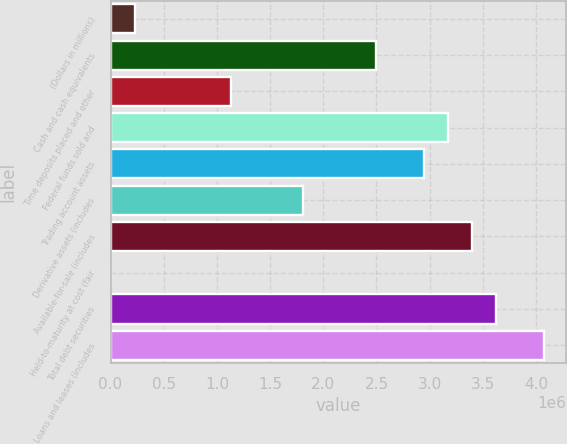<chart> <loc_0><loc_0><loc_500><loc_500><bar_chart><fcel>(Dollars in millions)<fcel>Cash and cash equivalents<fcel>Time deposits placed and other<fcel>Federal funds sold and<fcel>Trading account assets<fcel>Derivative assets (includes<fcel>Available-for-sale (includes<fcel>Held-to-maturity at cost (fair<fcel>Total debt securities<fcel>Loans and leases (includes<nl><fcel>226875<fcel>2.49136e+06<fcel>1.13267e+06<fcel>3.1707e+06<fcel>2.94425e+06<fcel>1.81201e+06<fcel>3.39715e+06<fcel>427<fcel>3.6236e+06<fcel>4.07649e+06<nl></chart> 